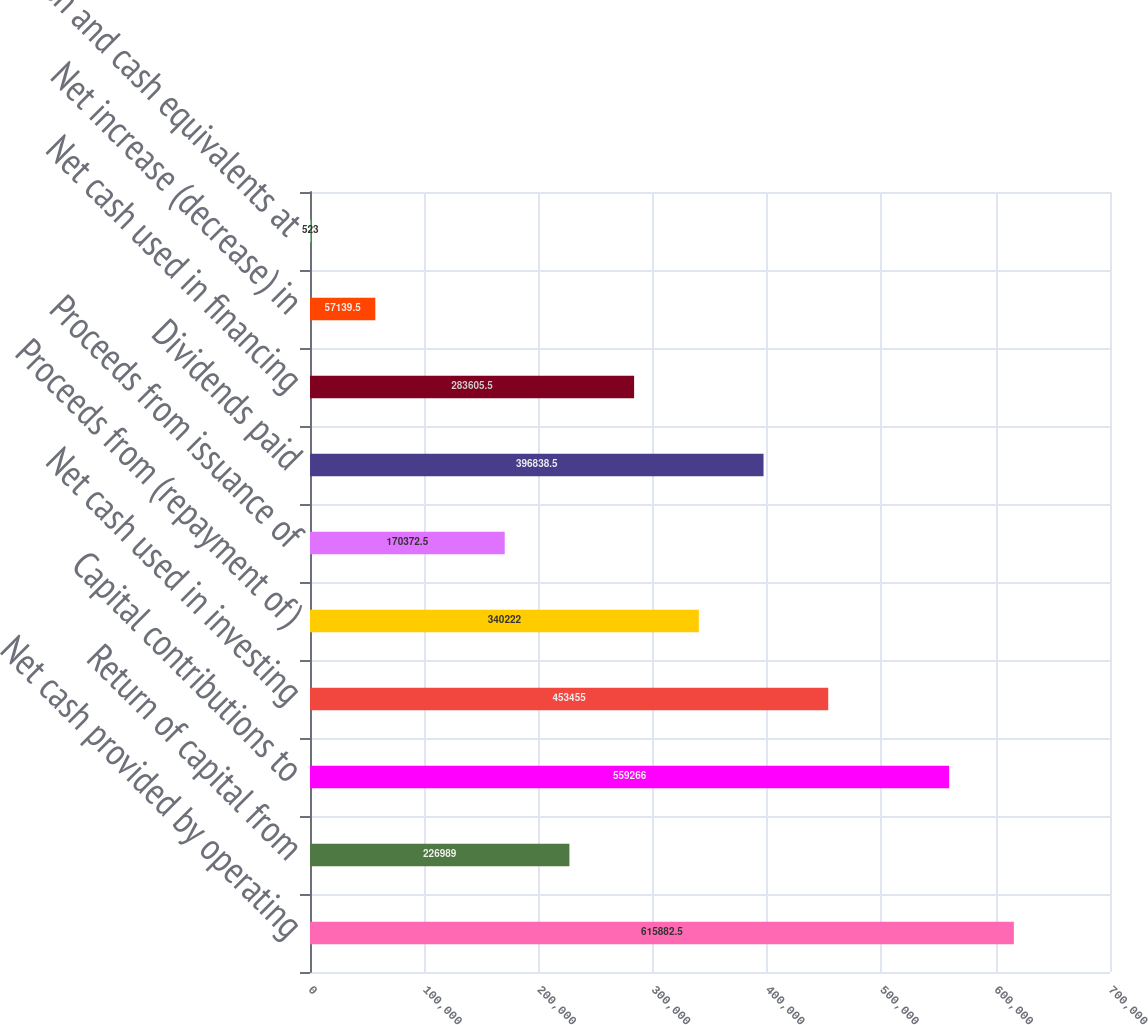Convert chart. <chart><loc_0><loc_0><loc_500><loc_500><bar_chart><fcel>Net cash provided by operating<fcel>Return of capital from<fcel>Capital contributions to<fcel>Net cash used in investing<fcel>Proceeds from (repayment of)<fcel>Proceeds from issuance of<fcel>Dividends paid<fcel>Net cash used in financing<fcel>Net increase (decrease) in<fcel>Cash and cash equivalents at<nl><fcel>615882<fcel>226989<fcel>559266<fcel>453455<fcel>340222<fcel>170372<fcel>396838<fcel>283606<fcel>57139.5<fcel>523<nl></chart> 